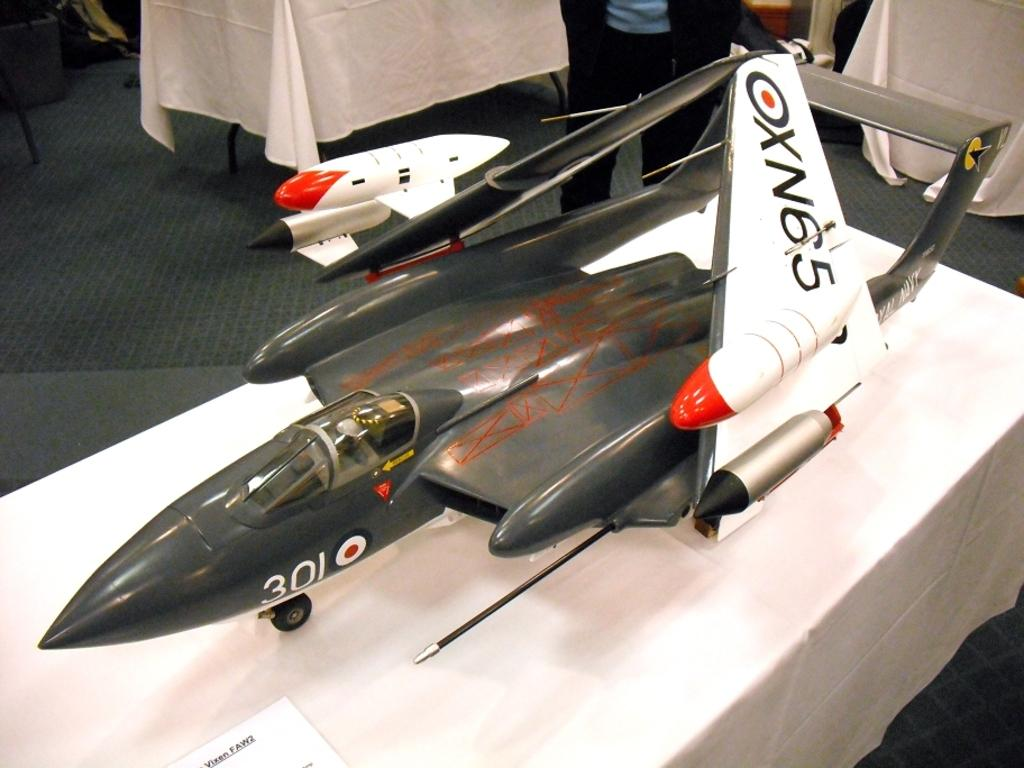<image>
Provide a brief description of the given image. A model airplane sitting on a white table with OXN65 written on the wing 